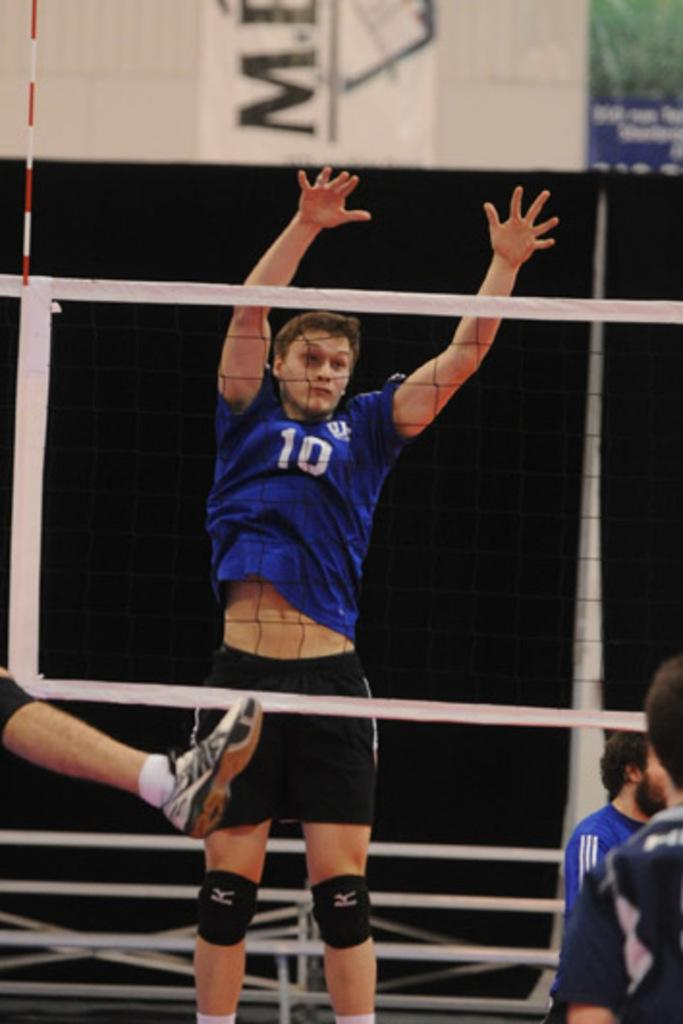<image>
Provide a brief description of the given image. Player number 10 in blue rises to try to block the ball in a volleyball match. 